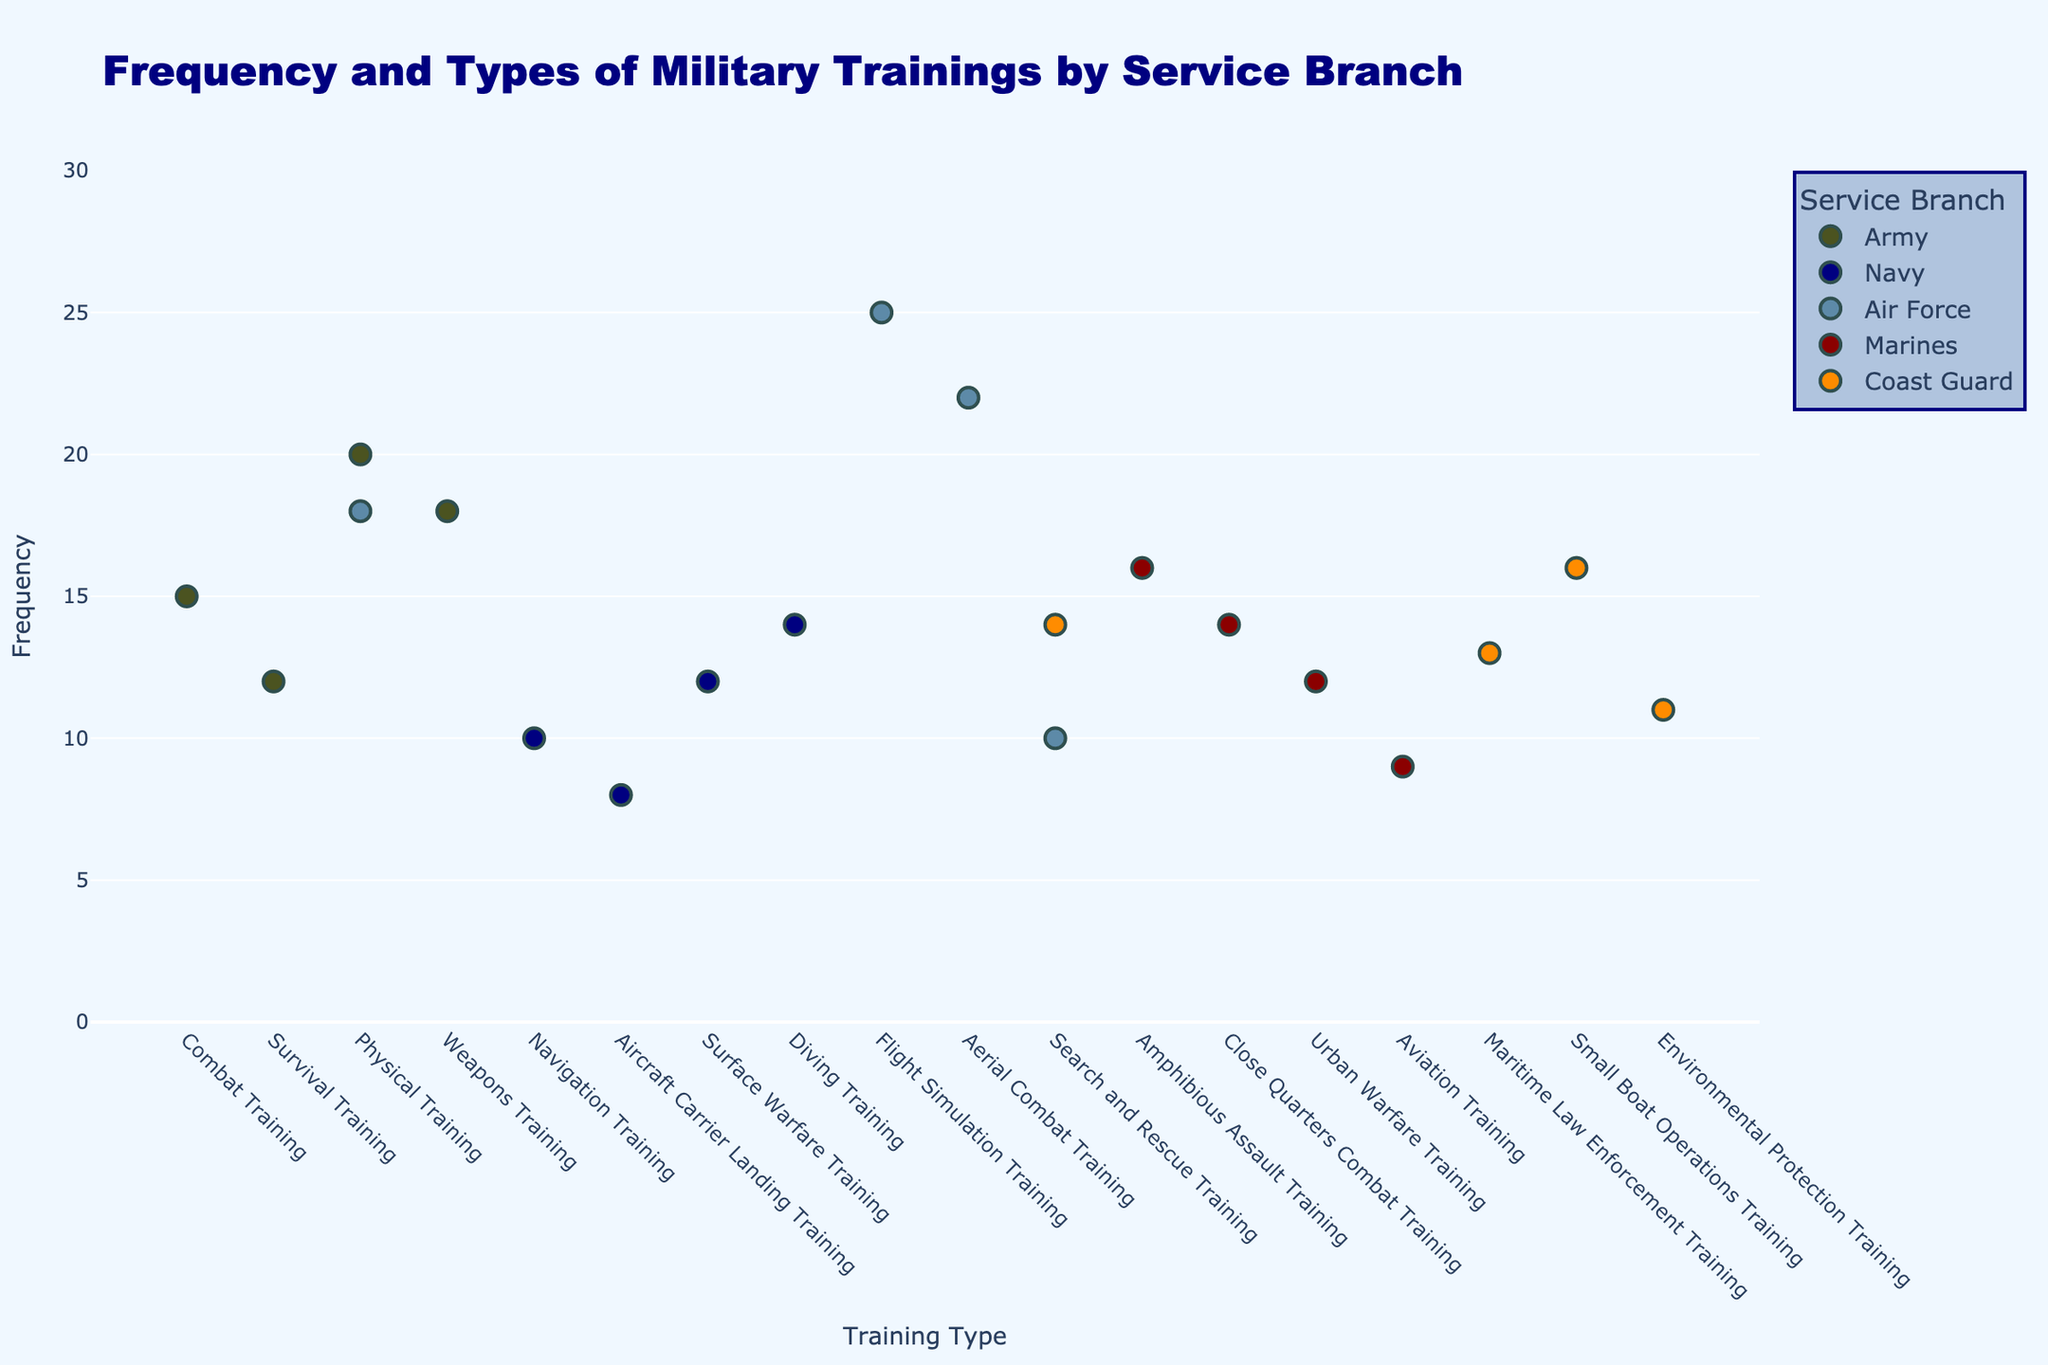1. What is the title of the plot? To find the title, look at the top of the plot where the main heading is displayed.
Answer: Frequency and Types of Military Trainings by Service Branch 2. Which service branch has the highest frequency of any training type, and what is that frequency? Find the highest point on the y-axis and check the corresponding service branch and training type.
Answer: Air Force, 25 3. How many different training types are listed for the Navy? Count the number of distinct training types associated with the Navy based on the x-axis labels.
Answer: 4 4. What is the frequency of Urban Warfare Training for the Marines? Locate the data point for Urban Warfare Training under the Marines category and read the y-axis value.
Answer: 12 5. Which training type does the Air Force have the lowest frequency in, and what is the frequency? Find the lowest y-axis point for the Air Force and identify the corresponding training type.
Answer: Search and Rescue Training, 10 6. Compare the frequency of Physical Training between the Army and the Air Force. Which one is higher, and by how much? Identify the y-axis values for Physical Training for both the Army and the Air Force and calculate the difference.
Answer: Army, by 2 7. What are the training types and their frequencies for the Coast Guard? List all the training types associated with the Coast Guard and their corresponding frequencies from the plot.
Answer: Search and Rescue Training: 14, Maritime Law Enforcement Training: 13, Small Boat Operations Training: 16, Environmental Protection Training: 11 8. Which service branch attends Search and Rescue Training the most frequently, and what is that frequency? Compare the y-axis values of Search and Rescue Training across different service branches to find the highest frequency.
Answer: Air Force, 10 9. What is the average frequency of training types attended by the Army? Sum the frequency of all training types attended by the Army and divide by the number of different training types.
Answer: (15 + 12 + 20 + 18) / 4 = 16.25 10. Determine if Navigation Training in the Navy or Survival Training in the Army is attended more frequently. Compare the y-axis values for Navigation Training in the Navy and Survival Training in the Army.
Answer: Survival Training in the Army 